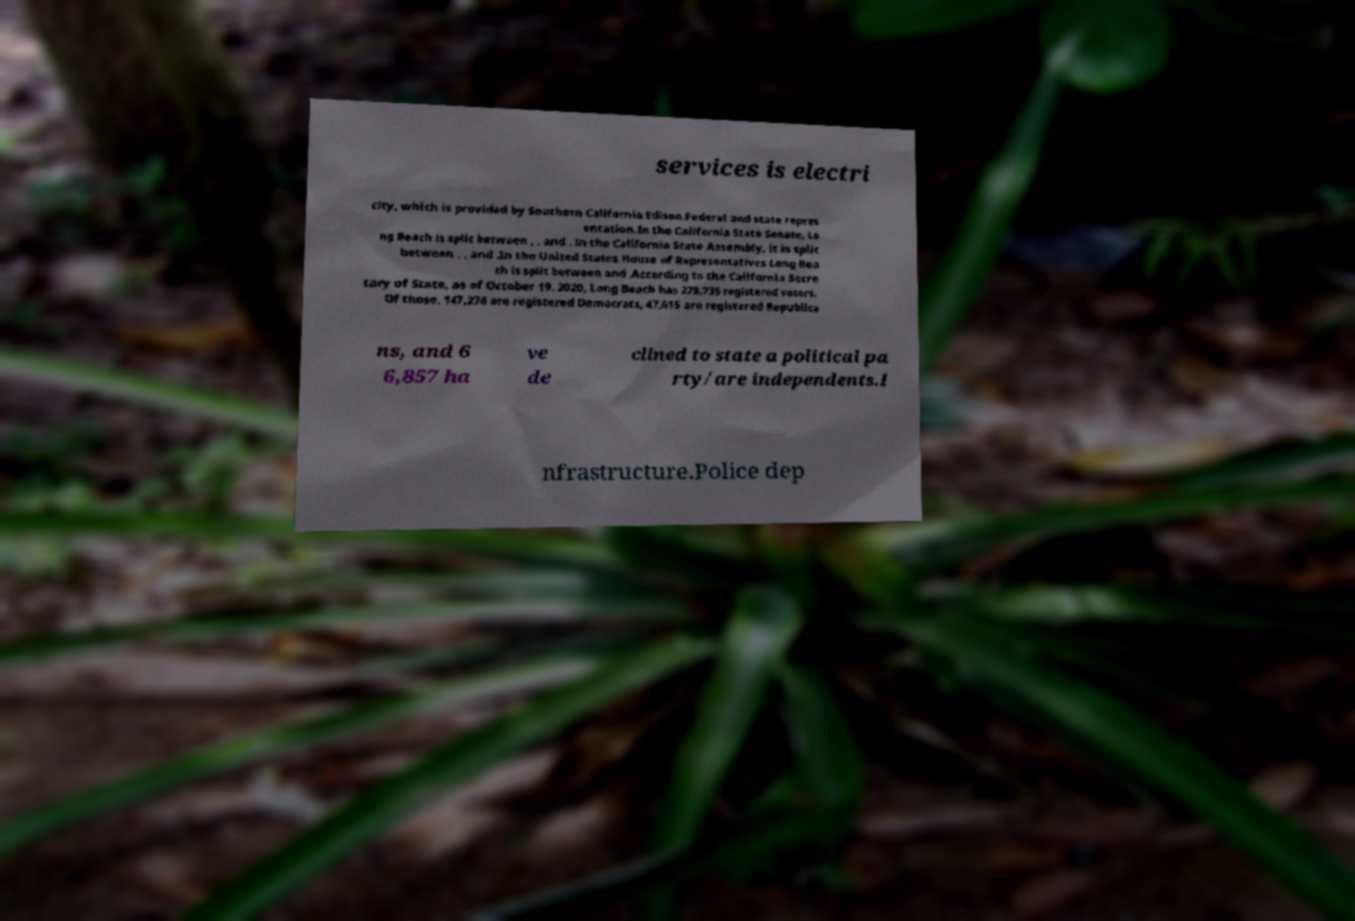Please read and relay the text visible in this image. What does it say? services is electri city, which is provided by Southern California Edison.Federal and state repres entation.In the California State Senate, Lo ng Beach is split between , , and . In the California State Assembly, it is split between , , and .In the United States House of Representatives Long Bea ch is split between and .According to the California Secre tary of State, as of October 19, 2020, Long Beach has 279,735 registered voters. Of those, 147,276 are registered Democrats, 47,615 are registered Republica ns, and 6 6,857 ha ve de clined to state a political pa rty/are independents.I nfrastructure.Police dep 